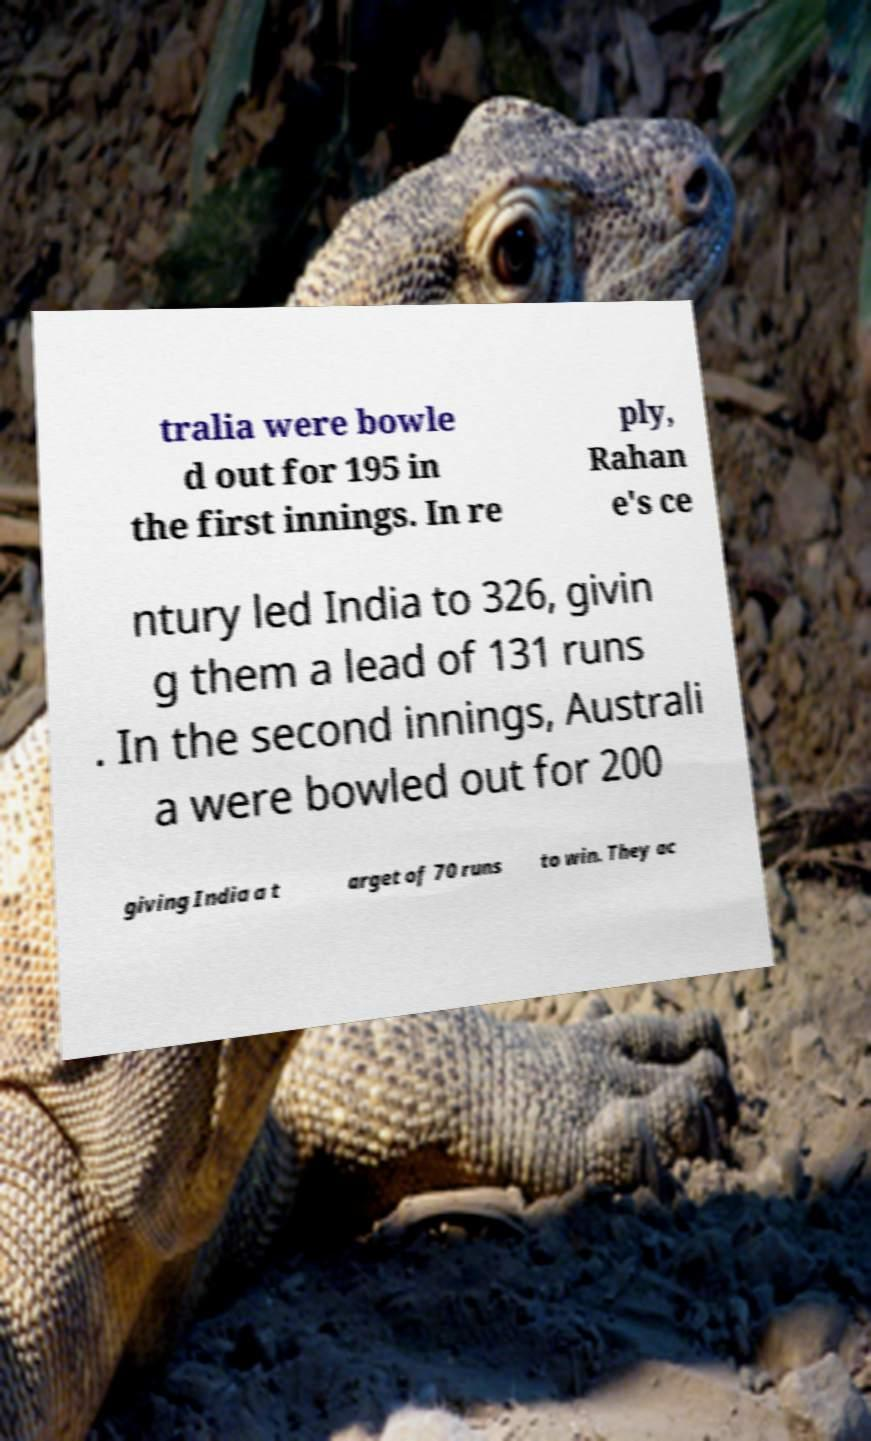Could you extract and type out the text from this image? tralia were bowle d out for 195 in the first innings. In re ply, Rahan e's ce ntury led India to 326, givin g them a lead of 131 runs . In the second innings, Australi a were bowled out for 200 giving India a t arget of 70 runs to win. They ac 